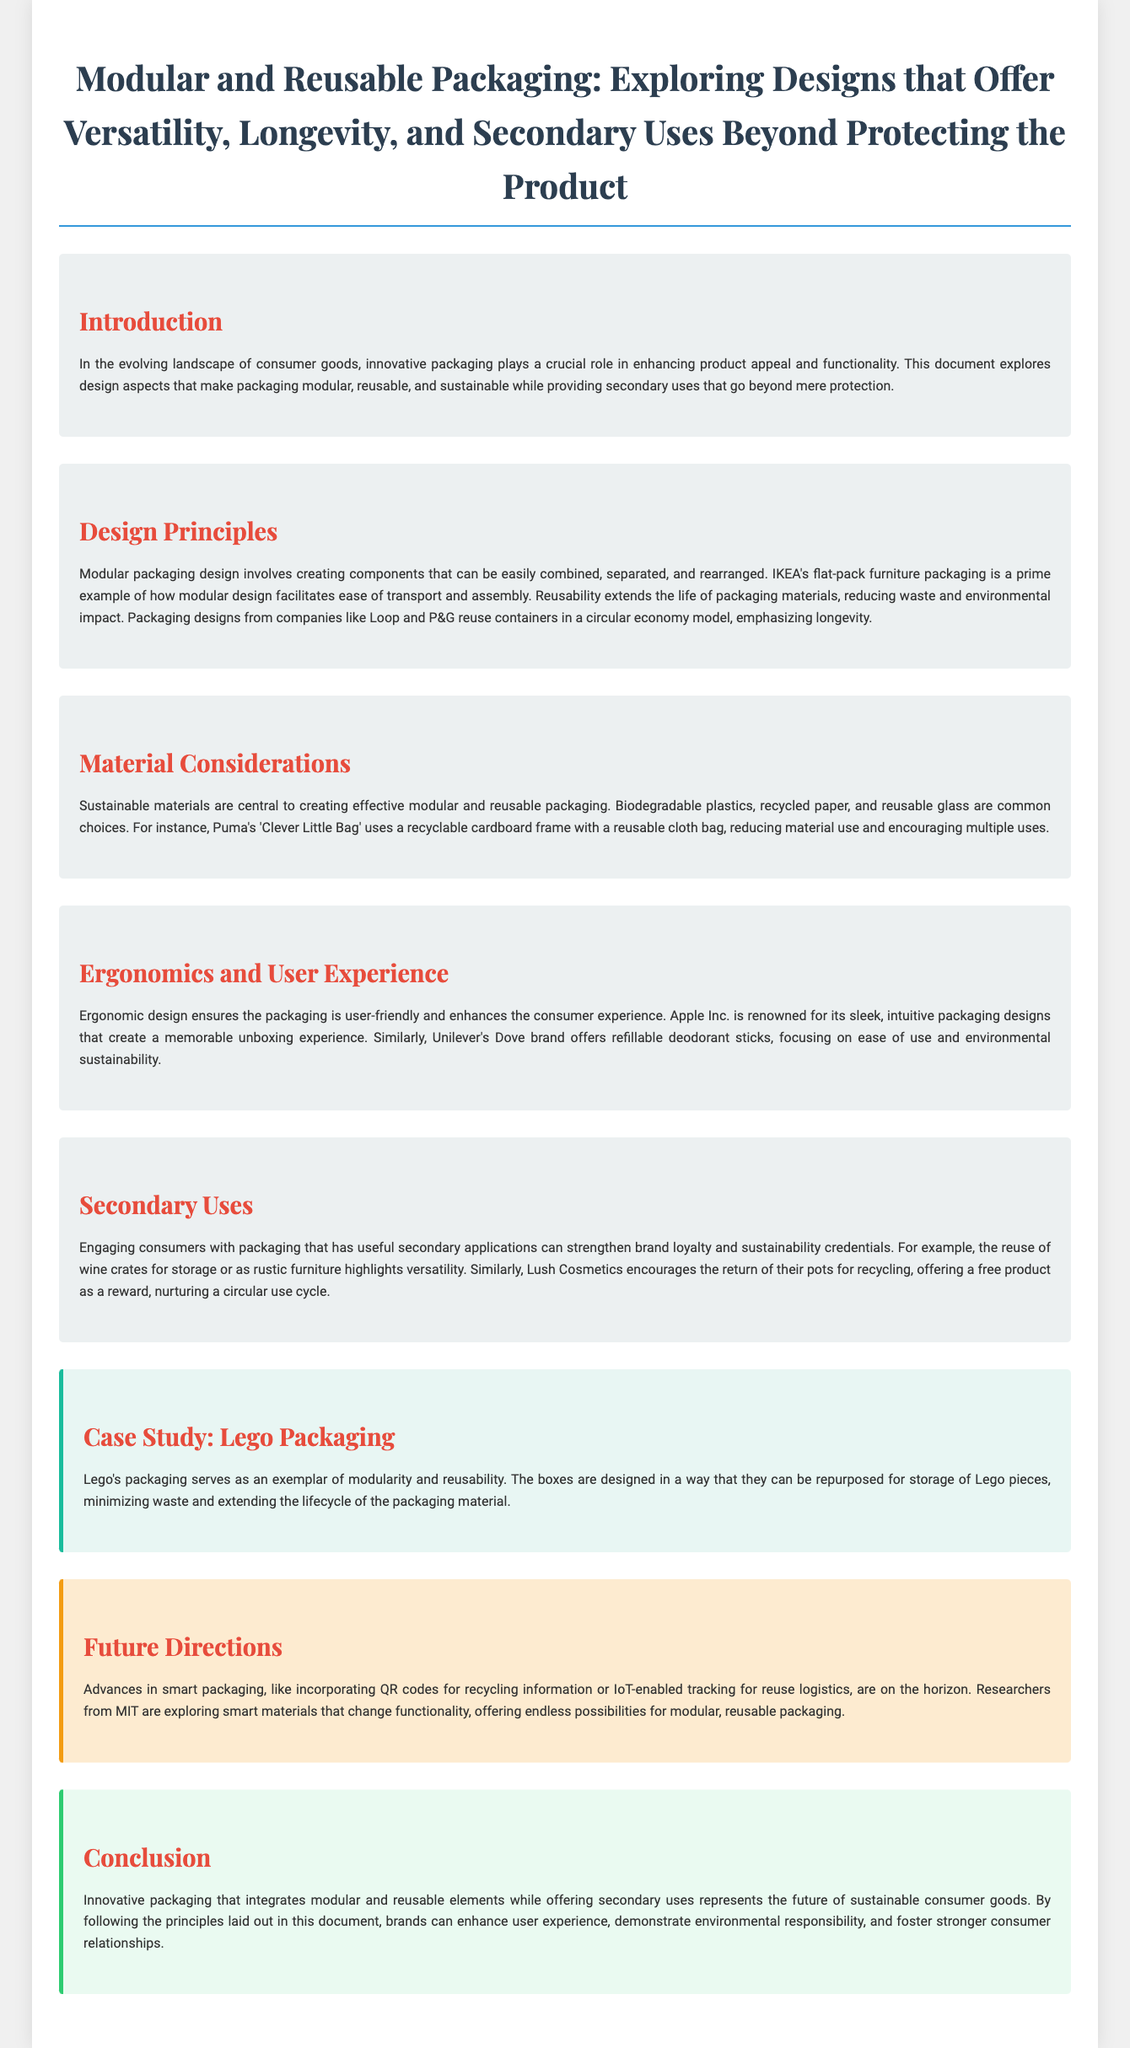What is the title of the document? The title is clearly stated at the top of the document and is related to modular and reusable packaging.
Answer: Modular and Reusable Packaging: Exploring Designs that Offer Versatility, Longevity, and Secondary Uses Beyond Protecting the Product Who is an example of a company implementing modular packaging? The document mentions IKEA's flat-pack furniture packaging as a prime example of modular design.
Answer: IKEA What sustainable material is mentioned in the document? The material considerations discuss specific sustainable materials, including biodegradable plastics and recycled paper.
Answer: Biodegradable plastics What user experience aspect is highlighted with Apple's packaging? The section on ergonomics and user experience talks about Apple's memorable unboxing experience.
Answer: Memorable unboxing experience What is a secondary use of wine crates mentioned? The document highlights the reuse of wine crates for storage or rustic furniture as an example of versatility.
Answer: Storage Which case study exemplifies modularity and reusability? The case study section specifically discusses Lego's packaging as an exemplar of modularity and reusability.
Answer: Lego's packaging What future advancement in packaging is noted in the document? The future directions section mentions smart packaging like QR codes for recycling information.
Answer: Smart packaging What is a reward offered by Lush Cosmetics for returning pots? The secondary uses section mentions that Lush offers a free product as a reward for pot returns.
Answer: Free product 